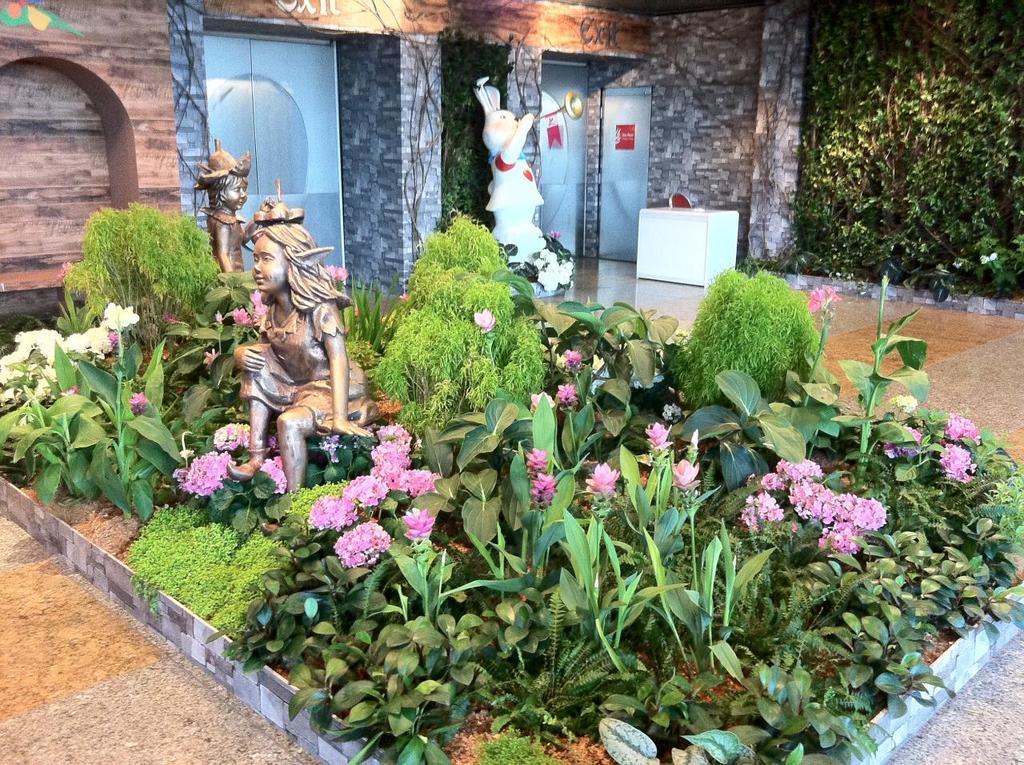How would you summarize this image in a sentence or two? In this image there are plants with flowers, sculptures, table, chair, doors. 